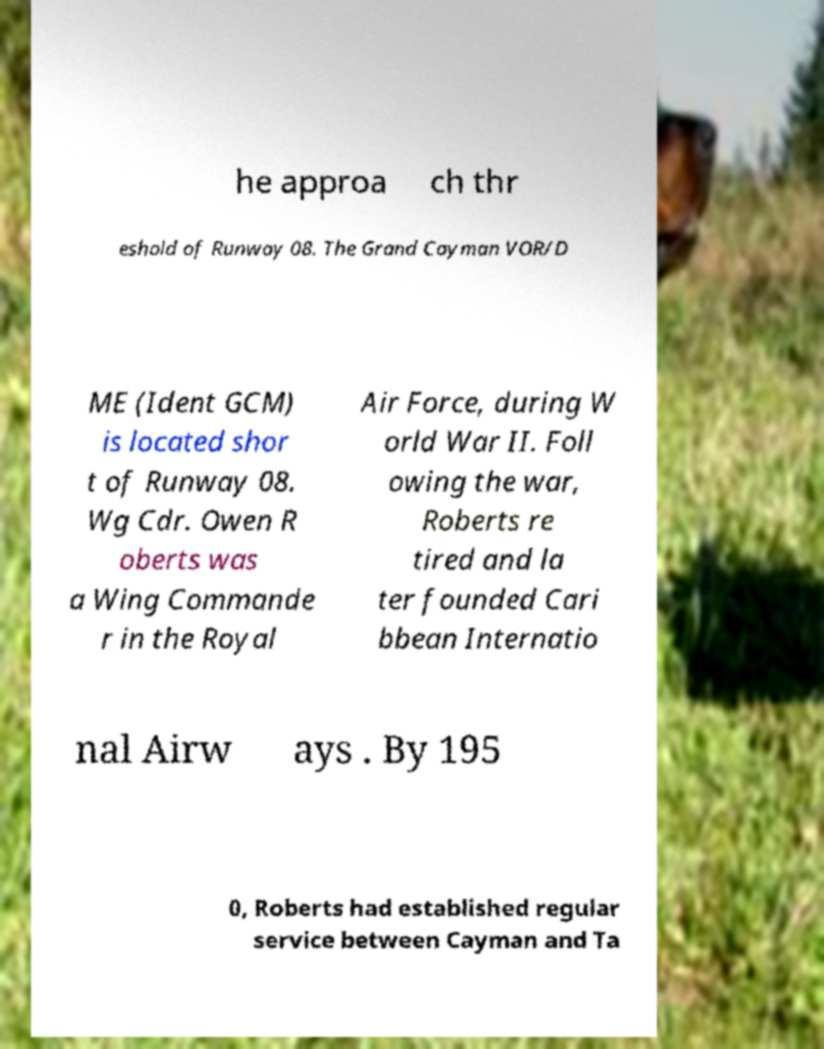I need the written content from this picture converted into text. Can you do that? he approa ch thr eshold of Runway 08. The Grand Cayman VOR/D ME (Ident GCM) is located shor t of Runway 08. Wg Cdr. Owen R oberts was a Wing Commande r in the Royal Air Force, during W orld War II. Foll owing the war, Roberts re tired and la ter founded Cari bbean Internatio nal Airw ays . By 195 0, Roberts had established regular service between Cayman and Ta 